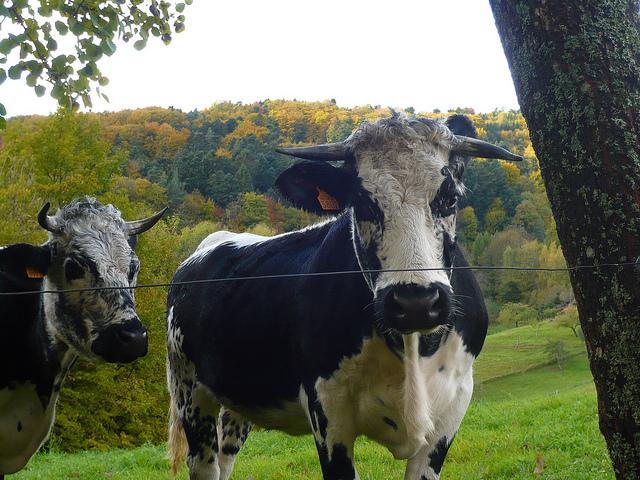What are these animals?
Keep it brief. Cows. What are the cows behind?
Keep it brief. Fence. Are the cows in a barn?
Keep it brief. No. 